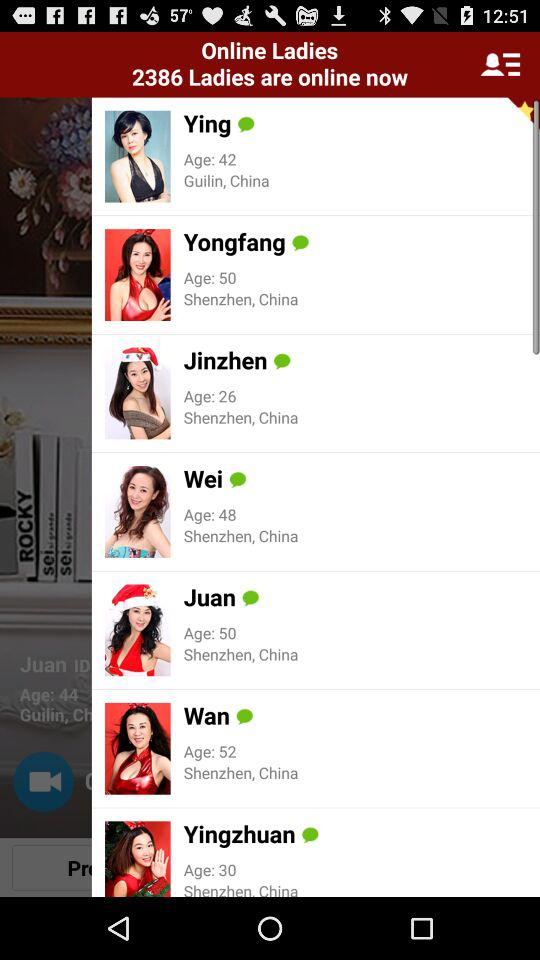What is the location of Wei? The location of Wei is Shenzhen, China. 